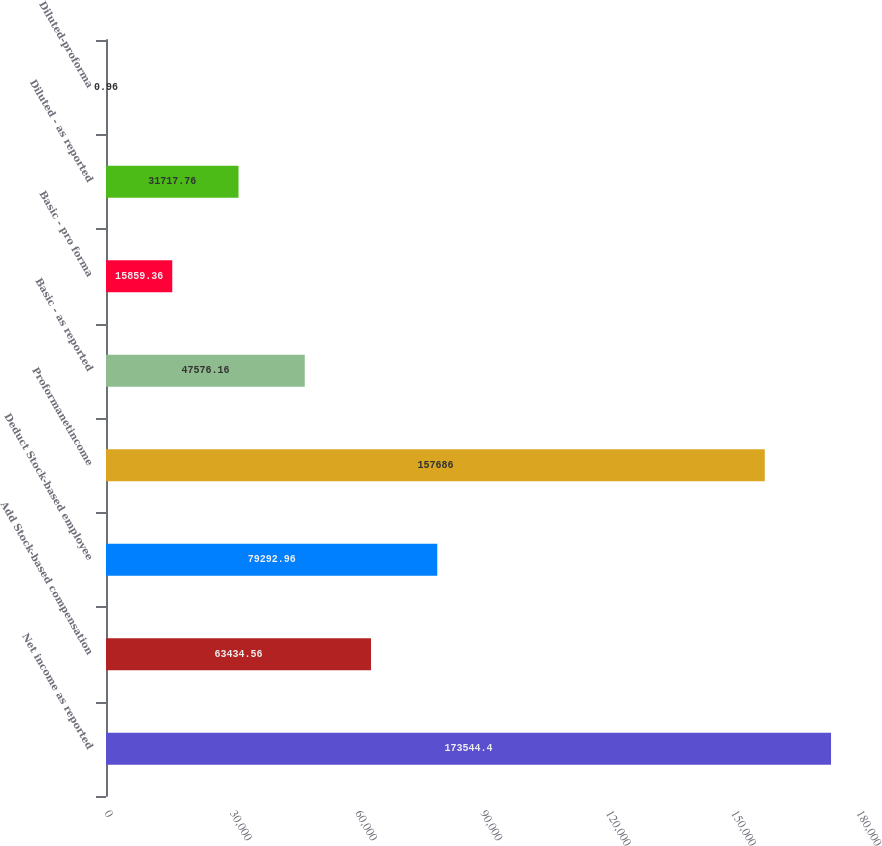<chart> <loc_0><loc_0><loc_500><loc_500><bar_chart><fcel>Net income as reported<fcel>Add Stock-based compensation<fcel>Deduct Stock-based employee<fcel>Proformanetincome<fcel>Basic - as reported<fcel>Basic - pro forma<fcel>Diluted - as reported<fcel>Diluted-proforma<nl><fcel>173544<fcel>63434.6<fcel>79293<fcel>157686<fcel>47576.2<fcel>15859.4<fcel>31717.8<fcel>0.96<nl></chart> 